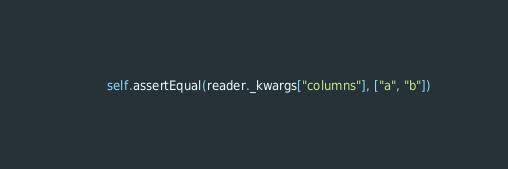<code> <loc_0><loc_0><loc_500><loc_500><_Python_>        self.assertEqual(reader._kwargs["columns"], ["a", "b"])</code> 